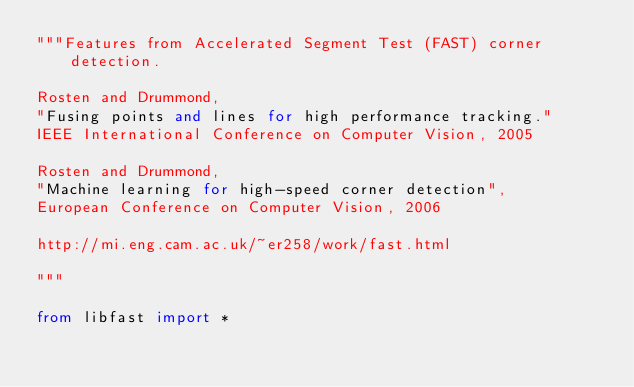<code> <loc_0><loc_0><loc_500><loc_500><_Python_>"""Features from Accelerated Segment Test (FAST) corner detection.

Rosten and Drummond,
"Fusing points and lines for high performance tracking."
IEEE International Conference on Computer Vision, 2005

Rosten and Drummond,
"Machine learning for high-speed corner detection",
European Conference on Computer Vision, 2006

http://mi.eng.cam.ac.uk/~er258/work/fast.html

"""

from libfast import *
</code> 